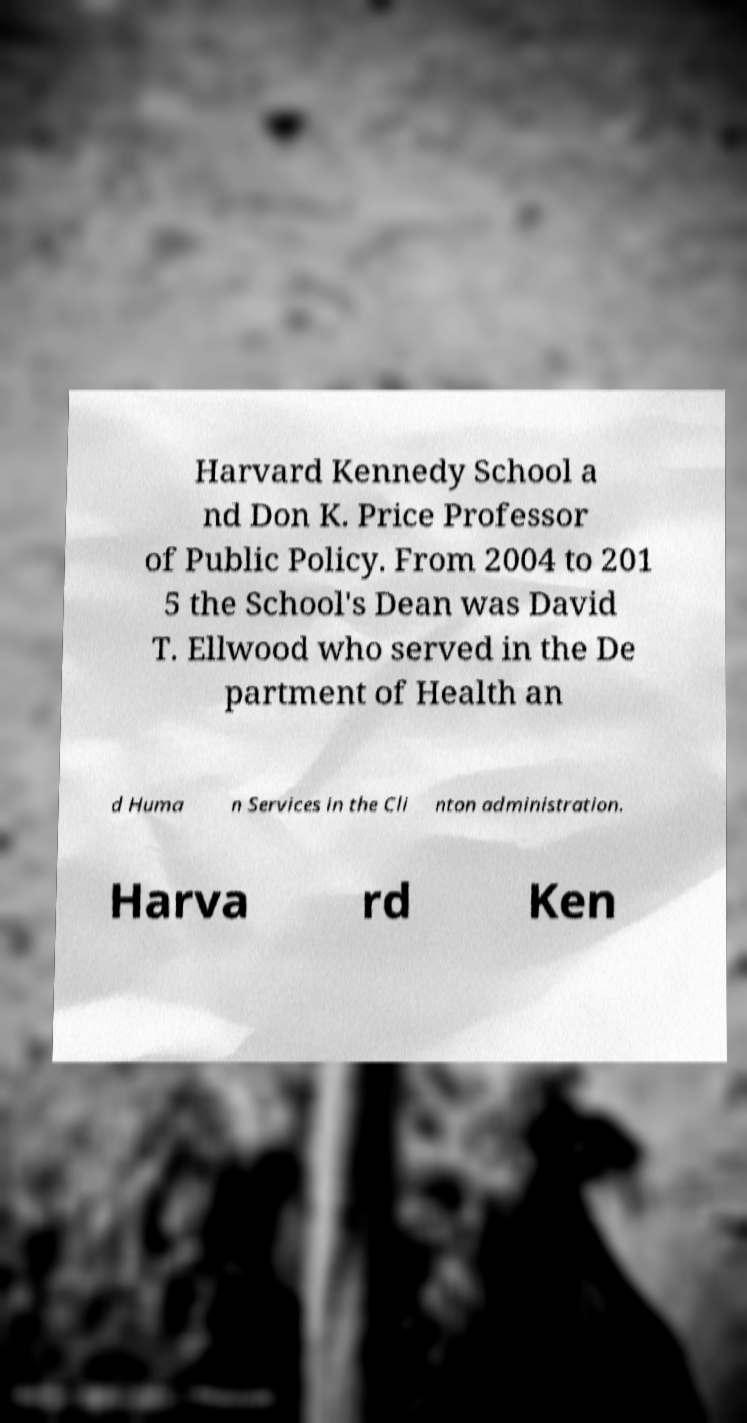For documentation purposes, I need the text within this image transcribed. Could you provide that? Harvard Kennedy School a nd Don K. Price Professor of Public Policy. From 2004 to 201 5 the School's Dean was David T. Ellwood who served in the De partment of Health an d Huma n Services in the Cli nton administration. Harva rd Ken 